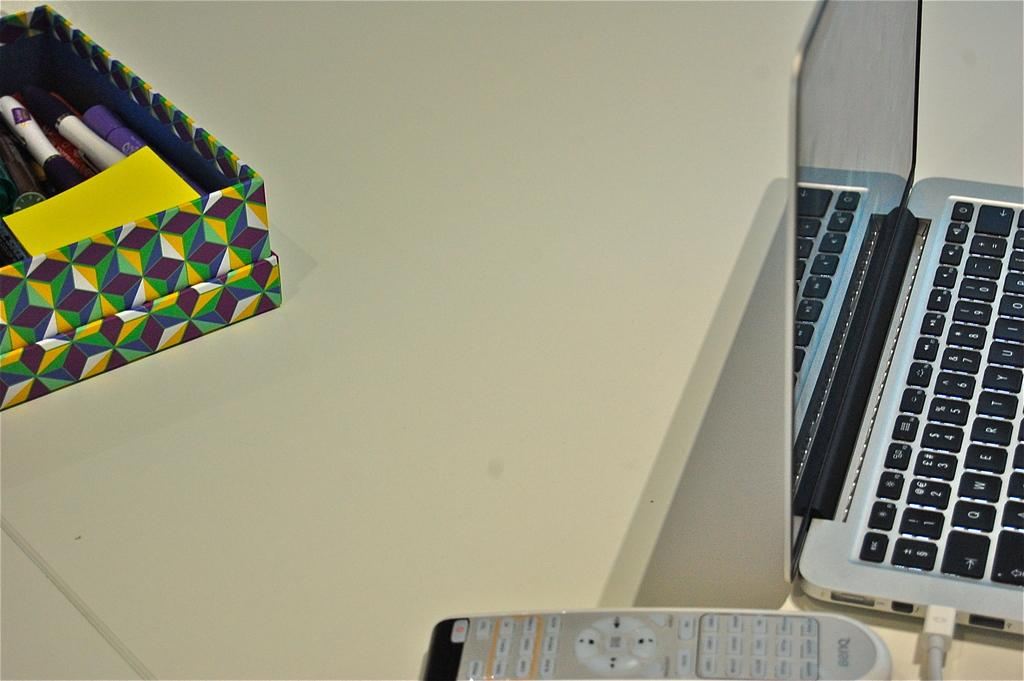What electronic device is located on the right side of the image? There is a laptop on the right side of the image. What object is in the front of the image? There is a remote in the front of the image. What is on the left side of the image? There is a box on the left side of the image. What items can be found inside the box? There are pens and a paper inside the box. What type of lamp is used for addition in the image? There is no lamp present in the image, and no addition is being performed. What type of business is being conducted in the image? There is no indication of any business being conducted in the image. 